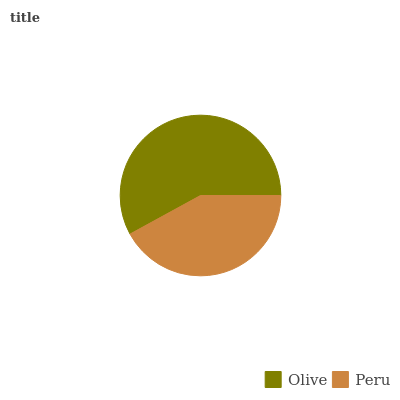Is Peru the minimum?
Answer yes or no. Yes. Is Olive the maximum?
Answer yes or no. Yes. Is Peru the maximum?
Answer yes or no. No. Is Olive greater than Peru?
Answer yes or no. Yes. Is Peru less than Olive?
Answer yes or no. Yes. Is Peru greater than Olive?
Answer yes or no. No. Is Olive less than Peru?
Answer yes or no. No. Is Olive the high median?
Answer yes or no. Yes. Is Peru the low median?
Answer yes or no. Yes. Is Peru the high median?
Answer yes or no. No. Is Olive the low median?
Answer yes or no. No. 